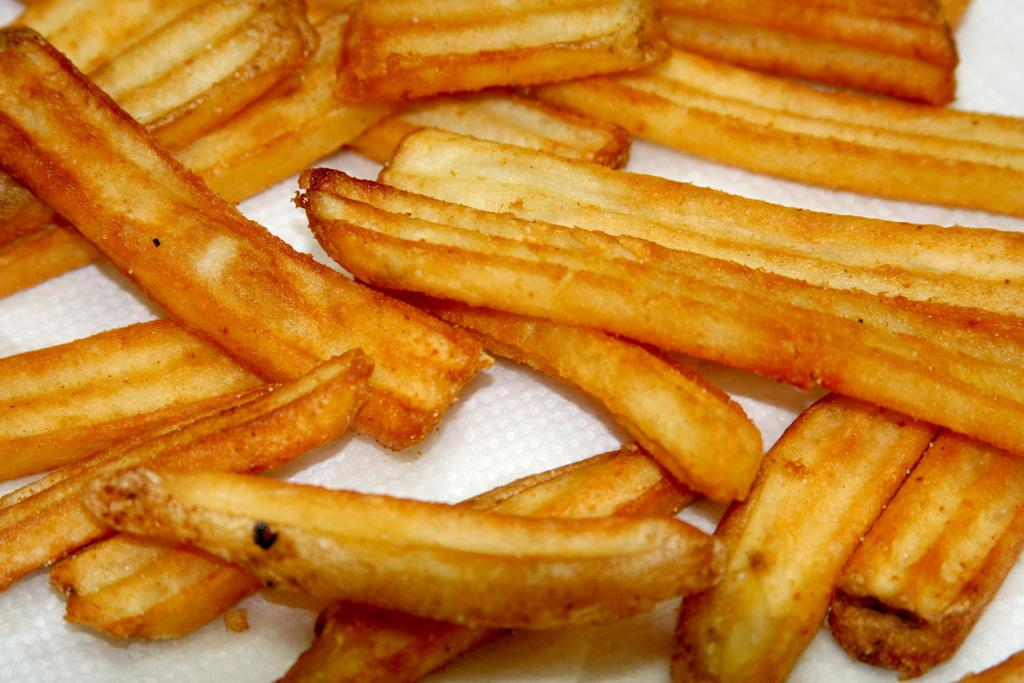What type of food is visible in the image? There are french fries in the image. What is the color of the french fries? The french fries are brown in color. What is the french fries placed on? The french fries are placed on a tissue. What is the color of the tissue? The tissue is white in color. Can you see any sand in the image? No, there is no sand present in the image. 